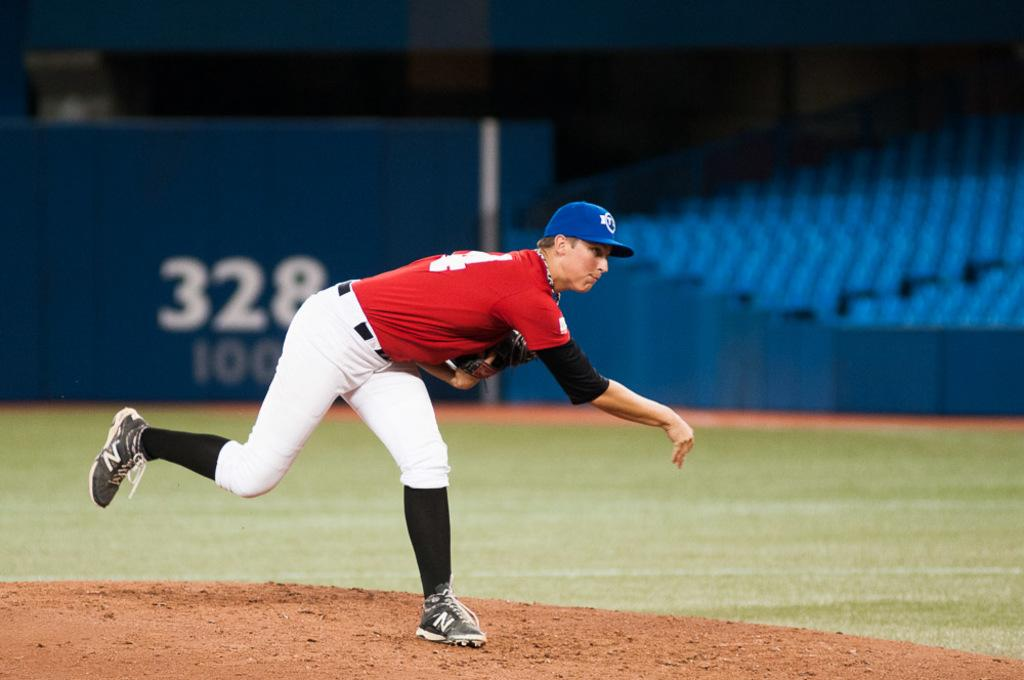<image>
Describe the image concisely. Professional baseball pitcher having just thrown the ball from the pitcher's mound. 